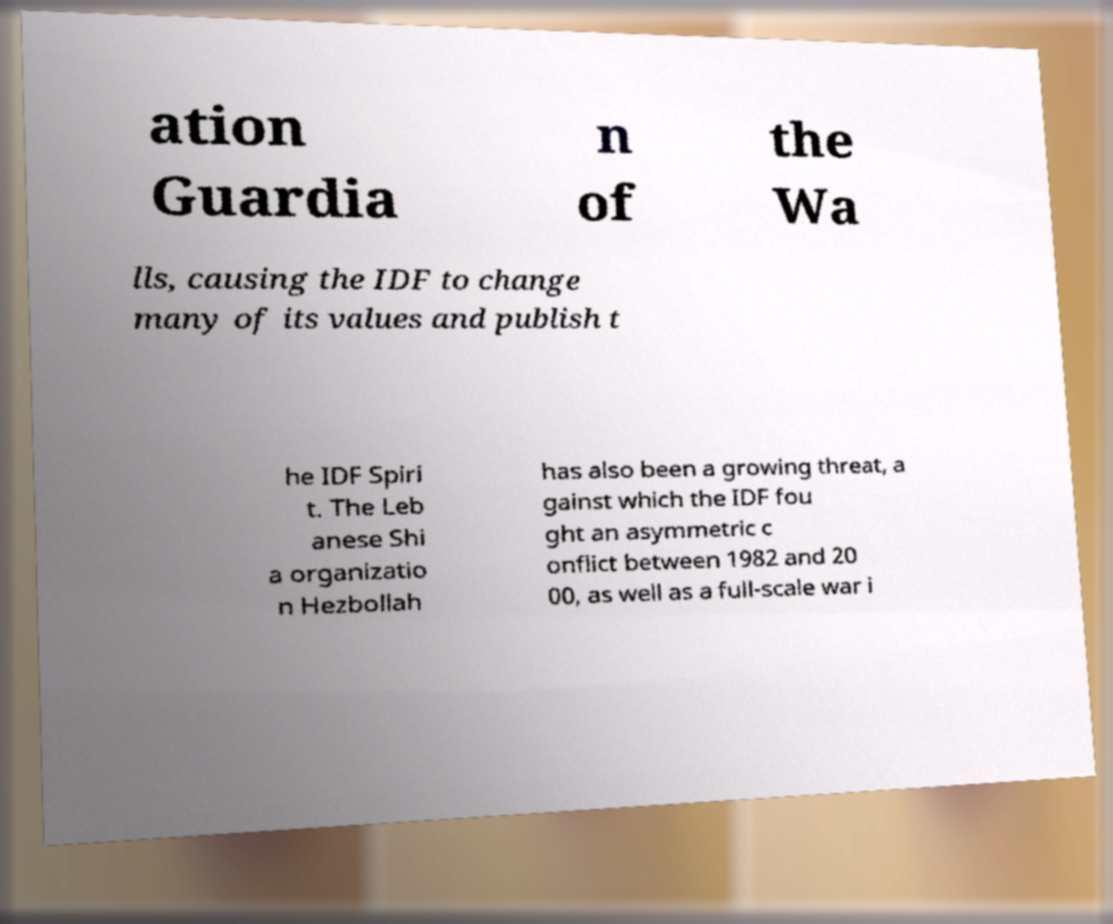Could you assist in decoding the text presented in this image and type it out clearly? ation Guardia n of the Wa lls, causing the IDF to change many of its values and publish t he IDF Spiri t. The Leb anese Shi a organizatio n Hezbollah has also been a growing threat, a gainst which the IDF fou ght an asymmetric c onflict between 1982 and 20 00, as well as a full-scale war i 